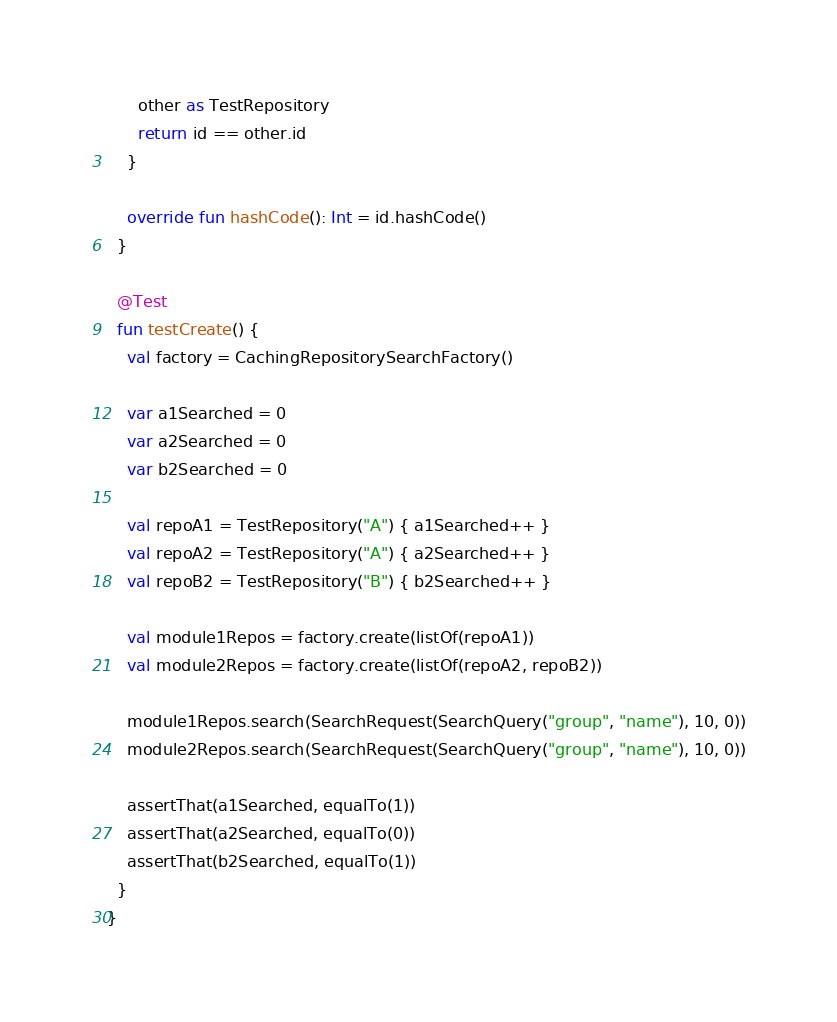Convert code to text. <code><loc_0><loc_0><loc_500><loc_500><_Kotlin_>      other as TestRepository
      return id == other.id
    }

    override fun hashCode(): Int = id.hashCode()
  }

  @Test
  fun testCreate() {
    val factory = CachingRepositorySearchFactory()

    var a1Searched = 0
    var a2Searched = 0
    var b2Searched = 0

    val repoA1 = TestRepository("A") { a1Searched++ }
    val repoA2 = TestRepository("A") { a2Searched++ }
    val repoB2 = TestRepository("B") { b2Searched++ }

    val module1Repos = factory.create(listOf(repoA1))
    val module2Repos = factory.create(listOf(repoA2, repoB2))

    module1Repos.search(SearchRequest(SearchQuery("group", "name"), 10, 0))
    module2Repos.search(SearchRequest(SearchQuery("group", "name"), 10, 0))

    assertThat(a1Searched, equalTo(1))
    assertThat(a2Searched, equalTo(0))
    assertThat(b2Searched, equalTo(1))
  }
}</code> 